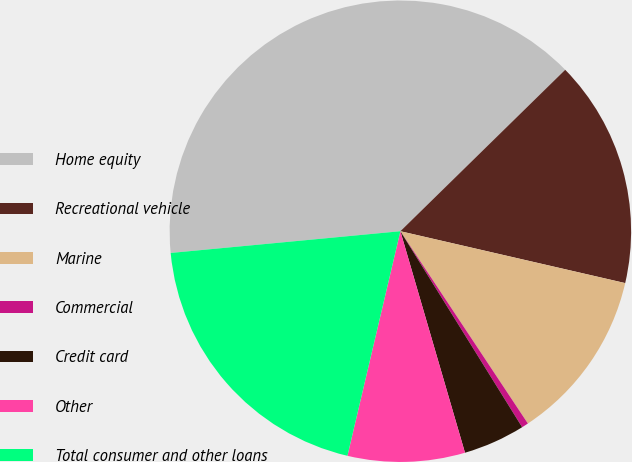<chart> <loc_0><loc_0><loc_500><loc_500><pie_chart><fcel>Home equity<fcel>Recreational vehicle<fcel>Marine<fcel>Commercial<fcel>Credit card<fcel>Other<fcel>Total consumer and other loans<nl><fcel>39.16%<fcel>15.94%<fcel>12.07%<fcel>0.47%<fcel>4.33%<fcel>8.2%<fcel>19.81%<nl></chart> 